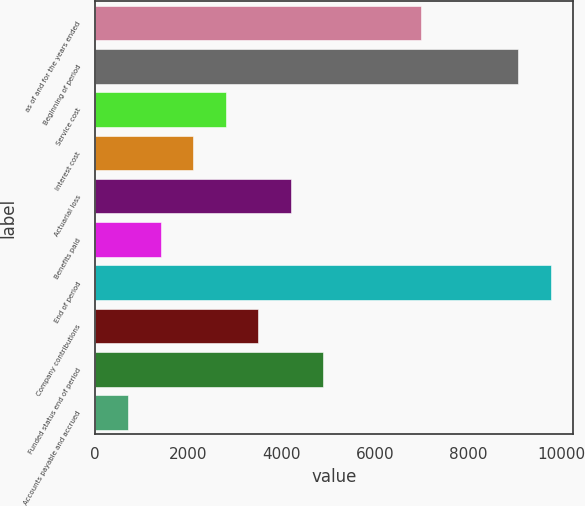Convert chart. <chart><loc_0><loc_0><loc_500><loc_500><bar_chart><fcel>as of and for the years ended<fcel>Beginning of period<fcel>Service cost<fcel>Interest cost<fcel>Actuarial loss<fcel>Benefits paid<fcel>End of period<fcel>Company contributions<fcel>Funded status end of period<fcel>Accounts payable and accrued<nl><fcel>6985<fcel>9076.9<fcel>2801.2<fcel>2103.9<fcel>4195.8<fcel>1406.6<fcel>9774.2<fcel>3498.5<fcel>4893.1<fcel>709.3<nl></chart> 